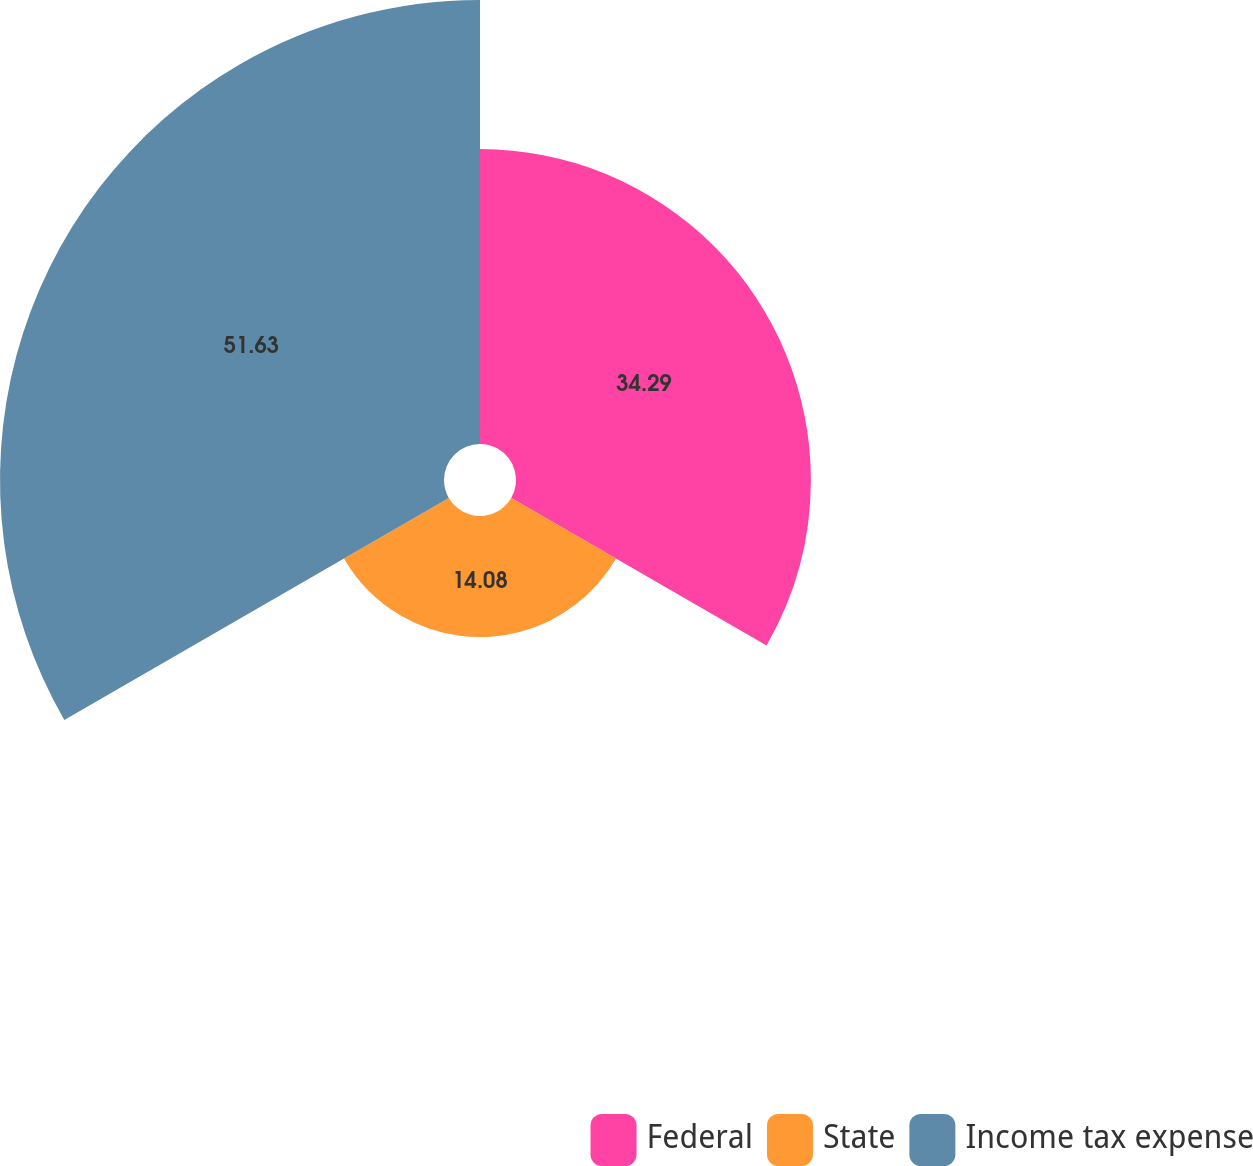Convert chart to OTSL. <chart><loc_0><loc_0><loc_500><loc_500><pie_chart><fcel>Federal<fcel>State<fcel>Income tax expense<nl><fcel>34.29%<fcel>14.08%<fcel>51.63%<nl></chart> 